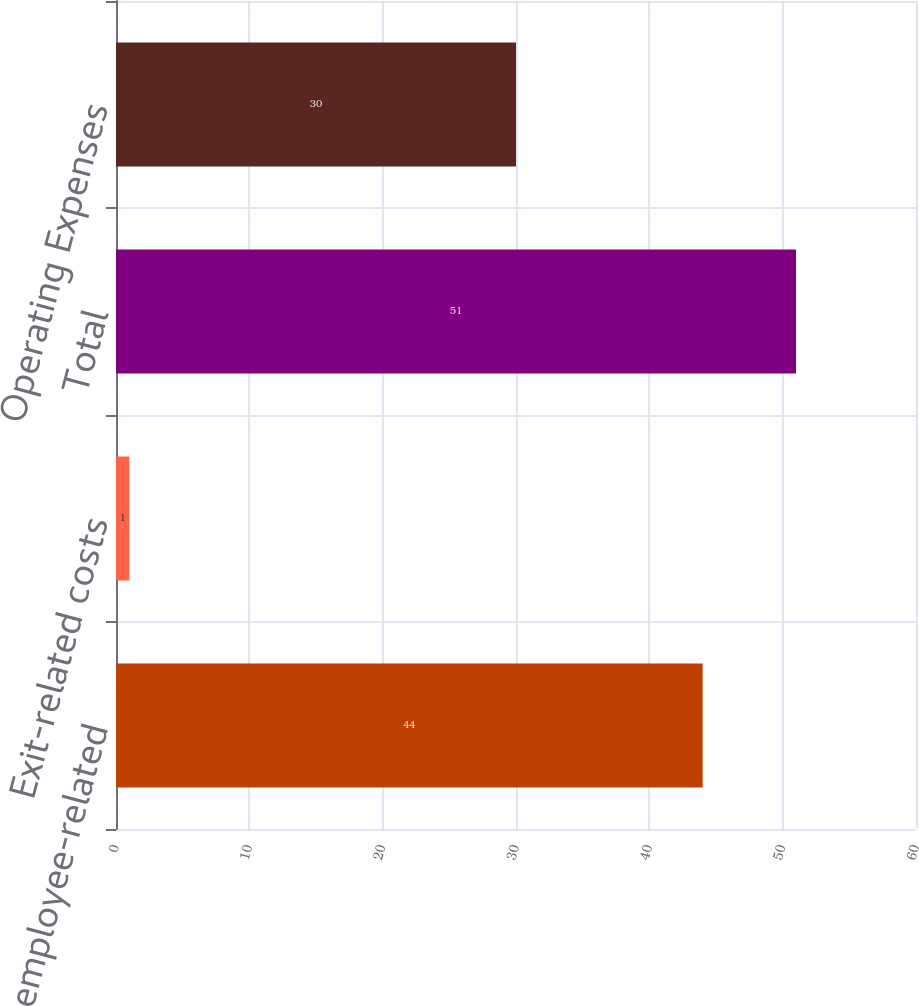Convert chart to OTSL. <chart><loc_0><loc_0><loc_500><loc_500><bar_chart><fcel>Severance and employee-related<fcel>Exit-related costs<fcel>Total<fcel>Operating Expenses<nl><fcel>44<fcel>1<fcel>51<fcel>30<nl></chart> 